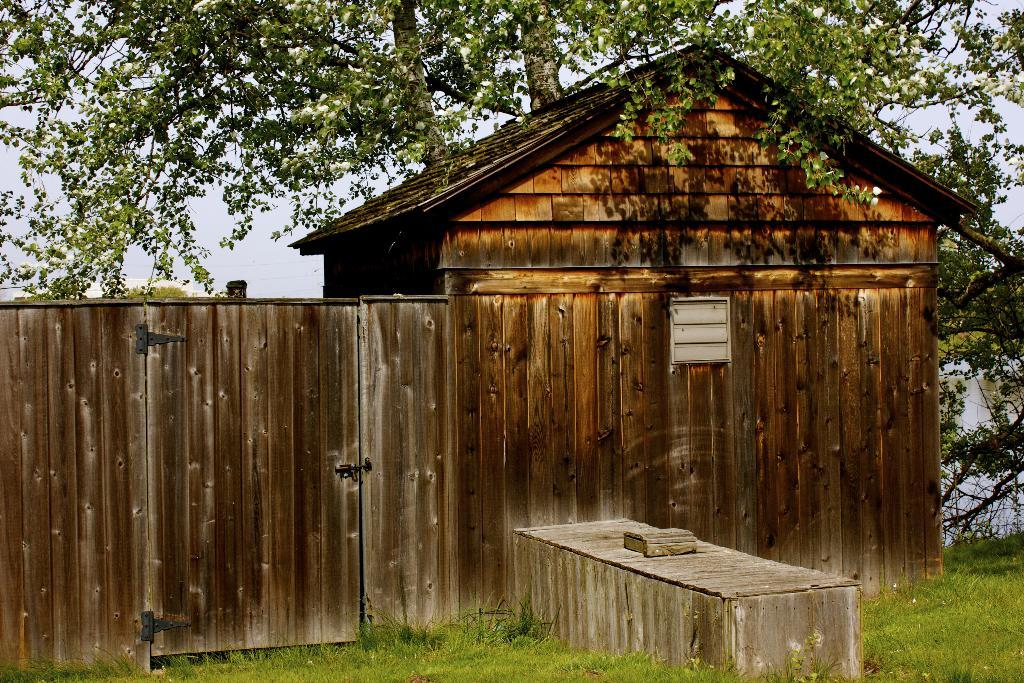What type of house is in the image? There is a wooden house in the image. What is located behind the house? There is a tree behind the house. What object is in front of the house? There is a wooden box in front of the house. What type of vegetation is present in the image? Grass is present in the image. Where is the pencil located in the image? There is no pencil present in the image. What type of park can be seen in the image? There is no park present in the image. 